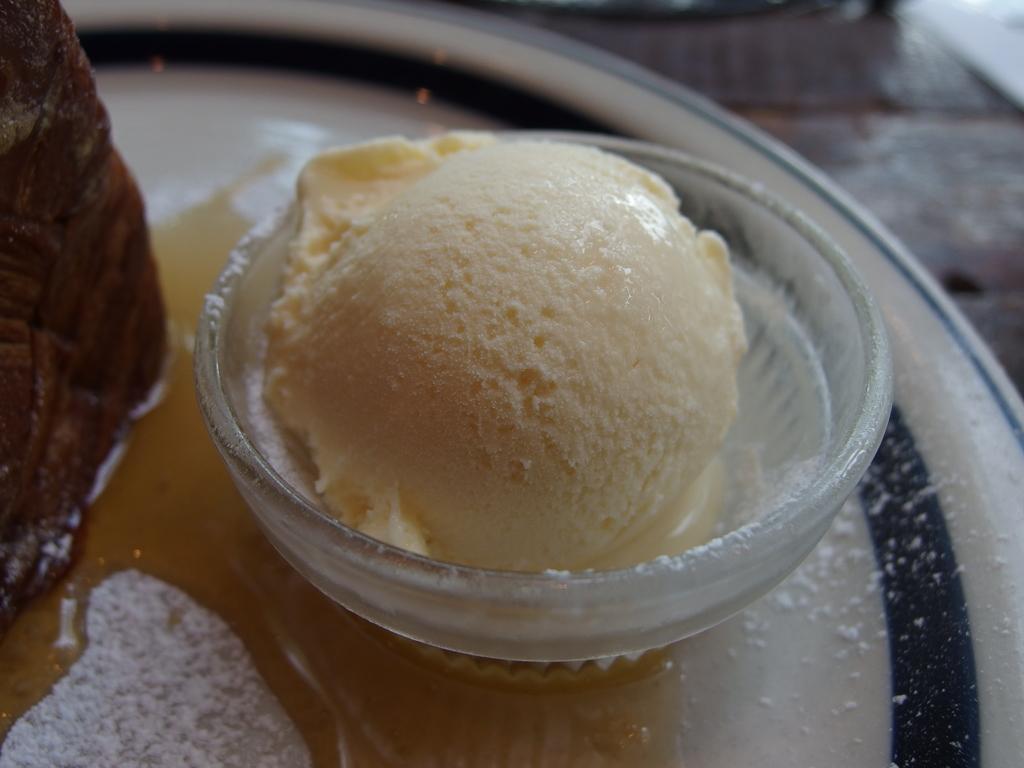Please provide a concise description of this image. In this image we can see an ice cream in the bowl and a food item, powder and other objects in the plate. In the background of the image there is a wooden texture. 